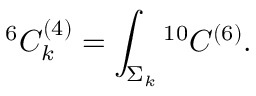<formula> <loc_0><loc_0><loc_500><loc_500>{ } ^ { 6 } C _ { k } ^ { ( 4 ) } = \int _ { \Sigma _ { k } ^ { 1 0 } C ^ { ( 6 ) } .</formula> 